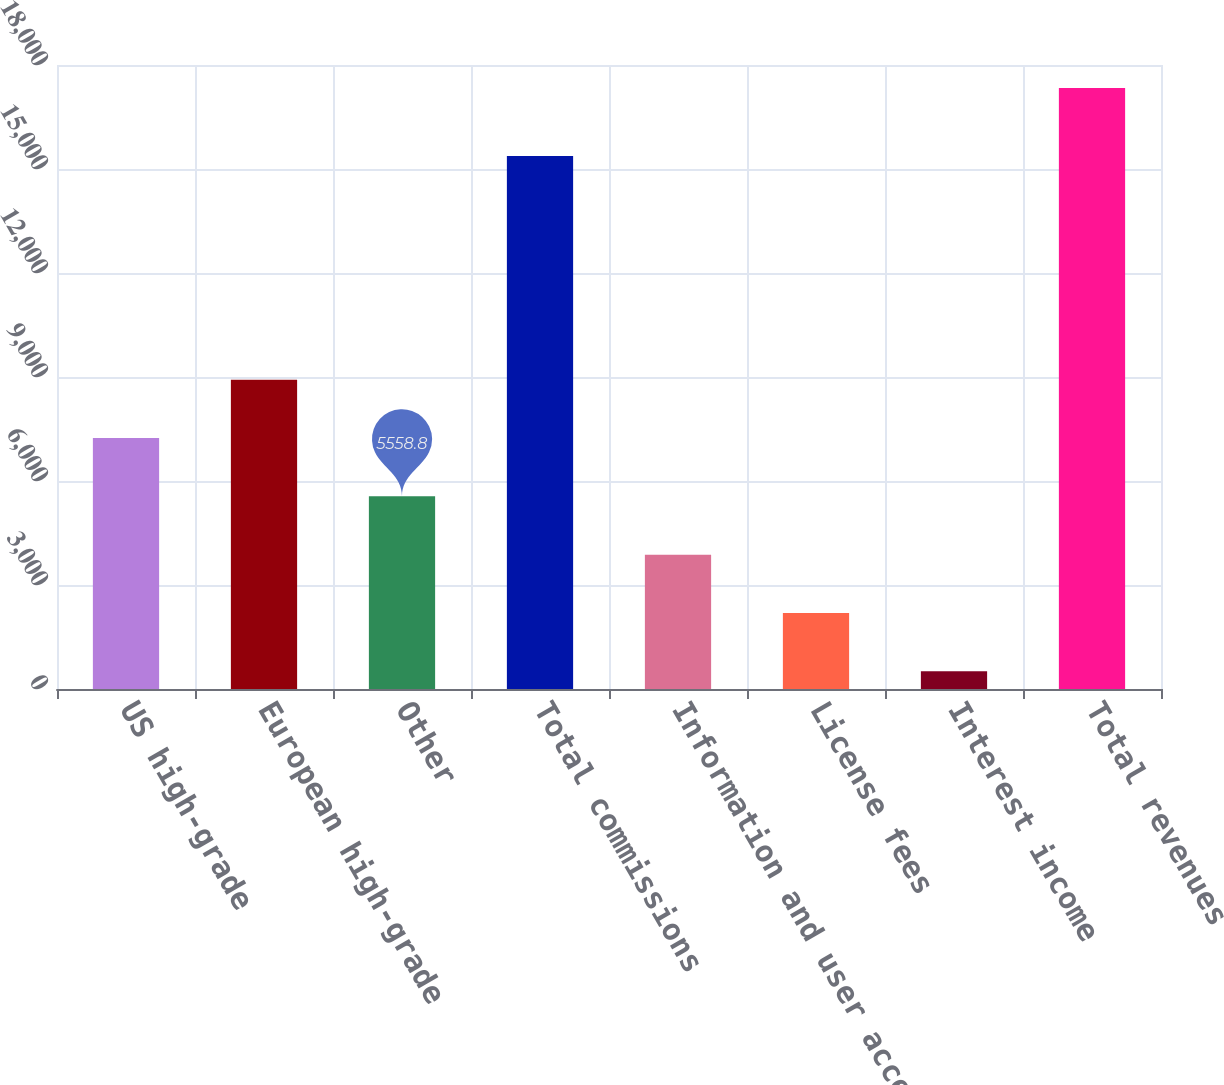Convert chart. <chart><loc_0><loc_0><loc_500><loc_500><bar_chart><fcel>US high-grade<fcel>European high-grade<fcel>Other<fcel>Total commissions<fcel>Information and user access<fcel>License fees<fcel>Interest income<fcel>Total revenues<nl><fcel>7241.4<fcel>8924<fcel>5558.8<fcel>15372<fcel>3876.2<fcel>2193.6<fcel>511<fcel>17337<nl></chart> 